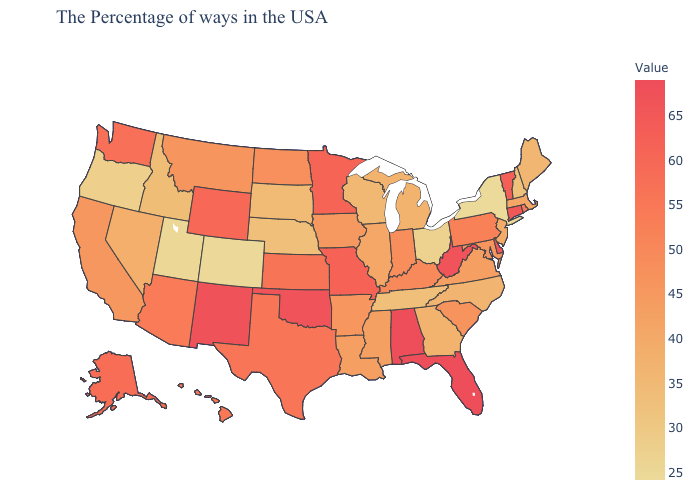Among the states that border South Dakota , does Nebraska have the lowest value?
Short answer required. Yes. Does Nevada have the highest value in the USA?
Write a very short answer. No. Does New Mexico have the highest value in the West?
Be succinct. Yes. Which states have the lowest value in the USA?
Write a very short answer. New York. Does Pennsylvania have the lowest value in the Northeast?
Short answer required. No. Among the states that border Texas , does Oklahoma have the highest value?
Be succinct. No. 